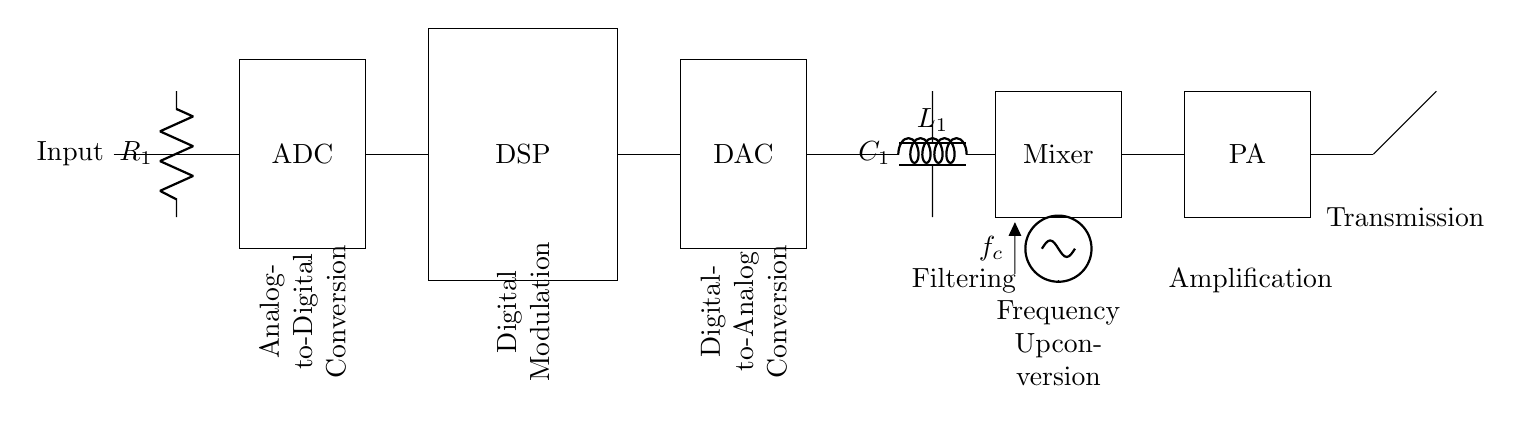What is the main function of the ADC in this circuit? The ADC, or Analog-to-Digital Converter, converts the input analog signal into a digital signal for processing. This is crucial for processing data in digital form.
Answer: Convert input signal What type of filter is used in this circuit? The circuit features a low-pass filter, which allows signals with a frequency lower than a certain cutoff frequency to pass through while attenuating higher frequencies. This is indicated by the label on the inductor and capacitor.
Answer: Low-pass filter How many main processing blocks are present in this digital modulation circuit? The circuit has five main processing blocks: ADC, DSP, DAC, Mixer, and PA. Each block serves a distinct function in encoding and transmitting the data.
Answer: Five What is the purpose of the local oscillator in this circuit? The local oscillator generates a carrier frequency that is mixed with the processed signal in the mixer, allowing frequency upconversion and enabling efficient transmission of the modulated signal.
Answer: Frequency generation Which component is responsible for amplifying the output signal before transmission? The Power Amplifier (PA) is responsible for amplifying the output signal, ensuring that it has sufficient power to be effectively transmitted through the antenna.
Answer: Power Amplifier What is the role of the DSP in the circuit? The Digital Signal Processor (DSP) processes the digital signal received from the ADC using various algorithms to encode the information for transmission. It plays a key role in digital modulation techniques.
Answer: Signal processing What might be the role of the antenna at the end of the circuit? The antenna transmits the modulated signal into the environment as electromagnetic waves, enabling wireless communication. It's crucial for the transmission process in telecommunications.
Answer: Wireless transmission 